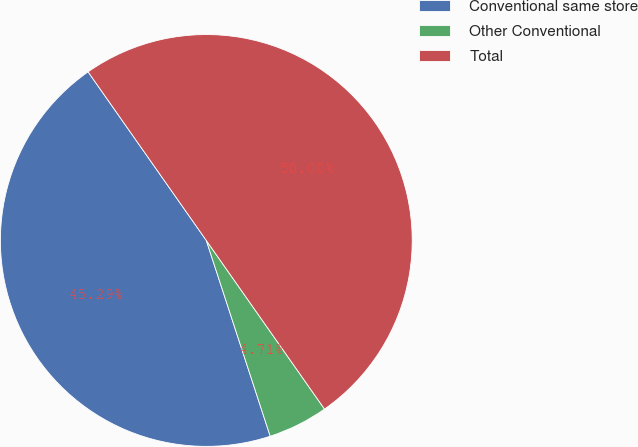Convert chart. <chart><loc_0><loc_0><loc_500><loc_500><pie_chart><fcel>Conventional same store<fcel>Other Conventional<fcel>Total<nl><fcel>45.29%<fcel>4.71%<fcel>50.0%<nl></chart> 